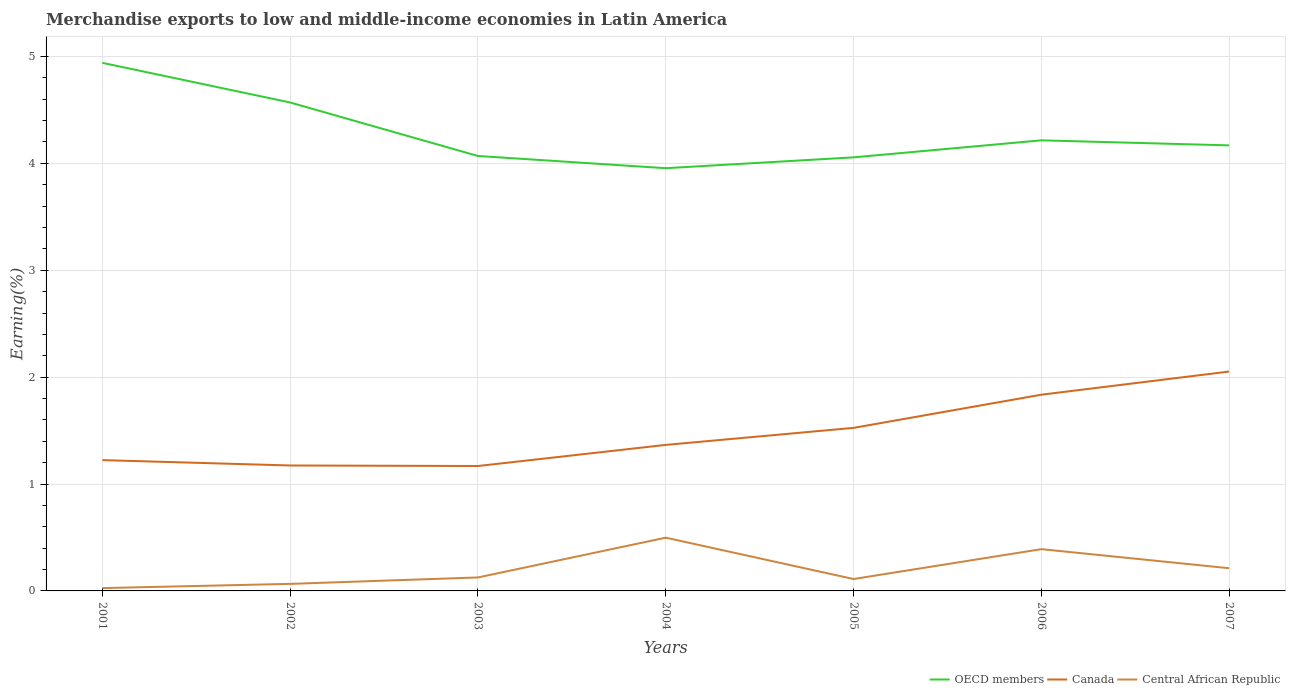How many different coloured lines are there?
Provide a short and direct response. 3. Across all years, what is the maximum percentage of amount earned from merchandise exports in OECD members?
Keep it short and to the point. 3.95. In which year was the percentage of amount earned from merchandise exports in Canada maximum?
Provide a succinct answer. 2003. What is the total percentage of amount earned from merchandise exports in Canada in the graph?
Give a very brief answer. -0.83. What is the difference between the highest and the second highest percentage of amount earned from merchandise exports in Canada?
Offer a terse response. 0.88. What is the difference between the highest and the lowest percentage of amount earned from merchandise exports in Central African Republic?
Your answer should be compact. 3. Is the percentage of amount earned from merchandise exports in Central African Republic strictly greater than the percentage of amount earned from merchandise exports in OECD members over the years?
Make the answer very short. Yes. How many years are there in the graph?
Your answer should be compact. 7. Are the values on the major ticks of Y-axis written in scientific E-notation?
Make the answer very short. No. Does the graph contain grids?
Offer a terse response. Yes. What is the title of the graph?
Your response must be concise. Merchandise exports to low and middle-income economies in Latin America. What is the label or title of the X-axis?
Your answer should be compact. Years. What is the label or title of the Y-axis?
Provide a succinct answer. Earning(%). What is the Earning(%) of OECD members in 2001?
Ensure brevity in your answer.  4.94. What is the Earning(%) in Canada in 2001?
Offer a very short reply. 1.22. What is the Earning(%) in Central African Republic in 2001?
Provide a succinct answer. 0.03. What is the Earning(%) in OECD members in 2002?
Your response must be concise. 4.57. What is the Earning(%) in Canada in 2002?
Provide a short and direct response. 1.17. What is the Earning(%) of Central African Republic in 2002?
Your answer should be compact. 0.07. What is the Earning(%) in OECD members in 2003?
Ensure brevity in your answer.  4.07. What is the Earning(%) of Canada in 2003?
Your answer should be compact. 1.17. What is the Earning(%) in Central African Republic in 2003?
Your answer should be compact. 0.13. What is the Earning(%) in OECD members in 2004?
Provide a succinct answer. 3.95. What is the Earning(%) of Canada in 2004?
Your answer should be very brief. 1.37. What is the Earning(%) of Central African Republic in 2004?
Your response must be concise. 0.5. What is the Earning(%) of OECD members in 2005?
Keep it short and to the point. 4.06. What is the Earning(%) of Canada in 2005?
Provide a short and direct response. 1.53. What is the Earning(%) of Central African Republic in 2005?
Make the answer very short. 0.11. What is the Earning(%) in OECD members in 2006?
Provide a succinct answer. 4.22. What is the Earning(%) in Canada in 2006?
Your answer should be very brief. 1.84. What is the Earning(%) in Central African Republic in 2006?
Ensure brevity in your answer.  0.39. What is the Earning(%) in OECD members in 2007?
Make the answer very short. 4.17. What is the Earning(%) of Canada in 2007?
Your answer should be compact. 2.05. What is the Earning(%) of Central African Republic in 2007?
Provide a succinct answer. 0.21. Across all years, what is the maximum Earning(%) of OECD members?
Your answer should be very brief. 4.94. Across all years, what is the maximum Earning(%) of Canada?
Make the answer very short. 2.05. Across all years, what is the maximum Earning(%) in Central African Republic?
Your response must be concise. 0.5. Across all years, what is the minimum Earning(%) of OECD members?
Your answer should be compact. 3.95. Across all years, what is the minimum Earning(%) in Canada?
Provide a succinct answer. 1.17. Across all years, what is the minimum Earning(%) in Central African Republic?
Provide a succinct answer. 0.03. What is the total Earning(%) in OECD members in the graph?
Your response must be concise. 29.97. What is the total Earning(%) of Canada in the graph?
Offer a terse response. 10.35. What is the total Earning(%) in Central African Republic in the graph?
Make the answer very short. 1.43. What is the difference between the Earning(%) of OECD members in 2001 and that in 2002?
Offer a terse response. 0.37. What is the difference between the Earning(%) in Canada in 2001 and that in 2002?
Ensure brevity in your answer.  0.05. What is the difference between the Earning(%) in Central African Republic in 2001 and that in 2002?
Provide a succinct answer. -0.04. What is the difference between the Earning(%) of OECD members in 2001 and that in 2003?
Provide a succinct answer. 0.87. What is the difference between the Earning(%) of Canada in 2001 and that in 2003?
Provide a short and direct response. 0.06. What is the difference between the Earning(%) in Central African Republic in 2001 and that in 2003?
Ensure brevity in your answer.  -0.1. What is the difference between the Earning(%) of OECD members in 2001 and that in 2004?
Keep it short and to the point. 0.99. What is the difference between the Earning(%) of Canada in 2001 and that in 2004?
Your answer should be compact. -0.14. What is the difference between the Earning(%) in Central African Republic in 2001 and that in 2004?
Your answer should be compact. -0.47. What is the difference between the Earning(%) in OECD members in 2001 and that in 2005?
Give a very brief answer. 0.88. What is the difference between the Earning(%) of Canada in 2001 and that in 2005?
Your answer should be very brief. -0.3. What is the difference between the Earning(%) in Central African Republic in 2001 and that in 2005?
Your answer should be very brief. -0.08. What is the difference between the Earning(%) in OECD members in 2001 and that in 2006?
Provide a succinct answer. 0.72. What is the difference between the Earning(%) in Canada in 2001 and that in 2006?
Provide a short and direct response. -0.61. What is the difference between the Earning(%) of Central African Republic in 2001 and that in 2006?
Offer a very short reply. -0.36. What is the difference between the Earning(%) of OECD members in 2001 and that in 2007?
Your answer should be very brief. 0.77. What is the difference between the Earning(%) of Canada in 2001 and that in 2007?
Your response must be concise. -0.83. What is the difference between the Earning(%) in Central African Republic in 2001 and that in 2007?
Make the answer very short. -0.19. What is the difference between the Earning(%) in OECD members in 2002 and that in 2003?
Provide a short and direct response. 0.5. What is the difference between the Earning(%) in Canada in 2002 and that in 2003?
Your response must be concise. 0. What is the difference between the Earning(%) in Central African Republic in 2002 and that in 2003?
Make the answer very short. -0.06. What is the difference between the Earning(%) of OECD members in 2002 and that in 2004?
Keep it short and to the point. 0.61. What is the difference between the Earning(%) of Canada in 2002 and that in 2004?
Provide a short and direct response. -0.19. What is the difference between the Earning(%) of Central African Republic in 2002 and that in 2004?
Your answer should be compact. -0.43. What is the difference between the Earning(%) in OECD members in 2002 and that in 2005?
Your answer should be compact. 0.51. What is the difference between the Earning(%) in Canada in 2002 and that in 2005?
Offer a very short reply. -0.35. What is the difference between the Earning(%) in Central African Republic in 2002 and that in 2005?
Keep it short and to the point. -0.05. What is the difference between the Earning(%) in OECD members in 2002 and that in 2006?
Make the answer very short. 0.35. What is the difference between the Earning(%) of Canada in 2002 and that in 2006?
Provide a short and direct response. -0.66. What is the difference between the Earning(%) of Central African Republic in 2002 and that in 2006?
Your answer should be very brief. -0.32. What is the difference between the Earning(%) in OECD members in 2002 and that in 2007?
Your answer should be compact. 0.4. What is the difference between the Earning(%) in Canada in 2002 and that in 2007?
Your answer should be very brief. -0.88. What is the difference between the Earning(%) in Central African Republic in 2002 and that in 2007?
Provide a short and direct response. -0.15. What is the difference between the Earning(%) of OECD members in 2003 and that in 2004?
Offer a very short reply. 0.11. What is the difference between the Earning(%) in Canada in 2003 and that in 2004?
Keep it short and to the point. -0.2. What is the difference between the Earning(%) of Central African Republic in 2003 and that in 2004?
Ensure brevity in your answer.  -0.37. What is the difference between the Earning(%) in OECD members in 2003 and that in 2005?
Provide a short and direct response. 0.01. What is the difference between the Earning(%) in Canada in 2003 and that in 2005?
Keep it short and to the point. -0.36. What is the difference between the Earning(%) of Central African Republic in 2003 and that in 2005?
Keep it short and to the point. 0.01. What is the difference between the Earning(%) in OECD members in 2003 and that in 2006?
Offer a terse response. -0.15. What is the difference between the Earning(%) in Canada in 2003 and that in 2006?
Give a very brief answer. -0.67. What is the difference between the Earning(%) of Central African Republic in 2003 and that in 2006?
Ensure brevity in your answer.  -0.26. What is the difference between the Earning(%) of OECD members in 2003 and that in 2007?
Your answer should be very brief. -0.1. What is the difference between the Earning(%) of Canada in 2003 and that in 2007?
Your response must be concise. -0.88. What is the difference between the Earning(%) of Central African Republic in 2003 and that in 2007?
Your answer should be compact. -0.09. What is the difference between the Earning(%) in OECD members in 2004 and that in 2005?
Offer a very short reply. -0.1. What is the difference between the Earning(%) of Canada in 2004 and that in 2005?
Give a very brief answer. -0.16. What is the difference between the Earning(%) in Central African Republic in 2004 and that in 2005?
Provide a short and direct response. 0.39. What is the difference between the Earning(%) of OECD members in 2004 and that in 2006?
Make the answer very short. -0.26. What is the difference between the Earning(%) of Canada in 2004 and that in 2006?
Your response must be concise. -0.47. What is the difference between the Earning(%) of Central African Republic in 2004 and that in 2006?
Your answer should be compact. 0.11. What is the difference between the Earning(%) in OECD members in 2004 and that in 2007?
Provide a short and direct response. -0.21. What is the difference between the Earning(%) in Canada in 2004 and that in 2007?
Your answer should be very brief. -0.69. What is the difference between the Earning(%) in Central African Republic in 2004 and that in 2007?
Make the answer very short. 0.29. What is the difference between the Earning(%) in OECD members in 2005 and that in 2006?
Give a very brief answer. -0.16. What is the difference between the Earning(%) of Canada in 2005 and that in 2006?
Offer a very short reply. -0.31. What is the difference between the Earning(%) of Central African Republic in 2005 and that in 2006?
Your response must be concise. -0.28. What is the difference between the Earning(%) of OECD members in 2005 and that in 2007?
Offer a terse response. -0.11. What is the difference between the Earning(%) in Canada in 2005 and that in 2007?
Give a very brief answer. -0.53. What is the difference between the Earning(%) in Central African Republic in 2005 and that in 2007?
Offer a very short reply. -0.1. What is the difference between the Earning(%) of OECD members in 2006 and that in 2007?
Offer a very short reply. 0.05. What is the difference between the Earning(%) of Canada in 2006 and that in 2007?
Ensure brevity in your answer.  -0.22. What is the difference between the Earning(%) in Central African Republic in 2006 and that in 2007?
Your answer should be very brief. 0.18. What is the difference between the Earning(%) in OECD members in 2001 and the Earning(%) in Canada in 2002?
Offer a very short reply. 3.77. What is the difference between the Earning(%) of OECD members in 2001 and the Earning(%) of Central African Republic in 2002?
Your answer should be compact. 4.87. What is the difference between the Earning(%) in Canada in 2001 and the Earning(%) in Central African Republic in 2002?
Ensure brevity in your answer.  1.16. What is the difference between the Earning(%) in OECD members in 2001 and the Earning(%) in Canada in 2003?
Your response must be concise. 3.77. What is the difference between the Earning(%) in OECD members in 2001 and the Earning(%) in Central African Republic in 2003?
Offer a terse response. 4.81. What is the difference between the Earning(%) in Canada in 2001 and the Earning(%) in Central African Republic in 2003?
Ensure brevity in your answer.  1.1. What is the difference between the Earning(%) in OECD members in 2001 and the Earning(%) in Canada in 2004?
Keep it short and to the point. 3.57. What is the difference between the Earning(%) of OECD members in 2001 and the Earning(%) of Central African Republic in 2004?
Your answer should be very brief. 4.44. What is the difference between the Earning(%) in Canada in 2001 and the Earning(%) in Central African Republic in 2004?
Your response must be concise. 0.73. What is the difference between the Earning(%) of OECD members in 2001 and the Earning(%) of Canada in 2005?
Your answer should be compact. 3.42. What is the difference between the Earning(%) in OECD members in 2001 and the Earning(%) in Central African Republic in 2005?
Your answer should be very brief. 4.83. What is the difference between the Earning(%) in Canada in 2001 and the Earning(%) in Central African Republic in 2005?
Provide a short and direct response. 1.11. What is the difference between the Earning(%) in OECD members in 2001 and the Earning(%) in Canada in 2006?
Provide a succinct answer. 3.1. What is the difference between the Earning(%) in OECD members in 2001 and the Earning(%) in Central African Republic in 2006?
Provide a short and direct response. 4.55. What is the difference between the Earning(%) in Canada in 2001 and the Earning(%) in Central African Republic in 2006?
Give a very brief answer. 0.83. What is the difference between the Earning(%) of OECD members in 2001 and the Earning(%) of Canada in 2007?
Ensure brevity in your answer.  2.89. What is the difference between the Earning(%) in OECD members in 2001 and the Earning(%) in Central African Republic in 2007?
Offer a very short reply. 4.73. What is the difference between the Earning(%) of Canada in 2001 and the Earning(%) of Central African Republic in 2007?
Your answer should be very brief. 1.01. What is the difference between the Earning(%) of OECD members in 2002 and the Earning(%) of Canada in 2003?
Offer a terse response. 3.4. What is the difference between the Earning(%) in OECD members in 2002 and the Earning(%) in Central African Republic in 2003?
Make the answer very short. 4.44. What is the difference between the Earning(%) of Canada in 2002 and the Earning(%) of Central African Republic in 2003?
Make the answer very short. 1.05. What is the difference between the Earning(%) of OECD members in 2002 and the Earning(%) of Canada in 2004?
Your answer should be very brief. 3.2. What is the difference between the Earning(%) in OECD members in 2002 and the Earning(%) in Central African Republic in 2004?
Provide a short and direct response. 4.07. What is the difference between the Earning(%) of Canada in 2002 and the Earning(%) of Central African Republic in 2004?
Your answer should be very brief. 0.68. What is the difference between the Earning(%) of OECD members in 2002 and the Earning(%) of Canada in 2005?
Offer a very short reply. 3.04. What is the difference between the Earning(%) of OECD members in 2002 and the Earning(%) of Central African Republic in 2005?
Offer a very short reply. 4.46. What is the difference between the Earning(%) of Canada in 2002 and the Earning(%) of Central African Republic in 2005?
Make the answer very short. 1.06. What is the difference between the Earning(%) of OECD members in 2002 and the Earning(%) of Canada in 2006?
Make the answer very short. 2.73. What is the difference between the Earning(%) in OECD members in 2002 and the Earning(%) in Central African Republic in 2006?
Your response must be concise. 4.18. What is the difference between the Earning(%) of Canada in 2002 and the Earning(%) of Central African Republic in 2006?
Make the answer very short. 0.78. What is the difference between the Earning(%) of OECD members in 2002 and the Earning(%) of Canada in 2007?
Give a very brief answer. 2.52. What is the difference between the Earning(%) of OECD members in 2002 and the Earning(%) of Central African Republic in 2007?
Give a very brief answer. 4.36. What is the difference between the Earning(%) of Canada in 2002 and the Earning(%) of Central African Republic in 2007?
Offer a terse response. 0.96. What is the difference between the Earning(%) of OECD members in 2003 and the Earning(%) of Canada in 2004?
Provide a short and direct response. 2.7. What is the difference between the Earning(%) in OECD members in 2003 and the Earning(%) in Central African Republic in 2004?
Ensure brevity in your answer.  3.57. What is the difference between the Earning(%) in Canada in 2003 and the Earning(%) in Central African Republic in 2004?
Offer a very short reply. 0.67. What is the difference between the Earning(%) of OECD members in 2003 and the Earning(%) of Canada in 2005?
Provide a short and direct response. 2.54. What is the difference between the Earning(%) in OECD members in 2003 and the Earning(%) in Central African Republic in 2005?
Keep it short and to the point. 3.96. What is the difference between the Earning(%) of Canada in 2003 and the Earning(%) of Central African Republic in 2005?
Your response must be concise. 1.06. What is the difference between the Earning(%) of OECD members in 2003 and the Earning(%) of Canada in 2006?
Provide a short and direct response. 2.23. What is the difference between the Earning(%) in OECD members in 2003 and the Earning(%) in Central African Republic in 2006?
Make the answer very short. 3.68. What is the difference between the Earning(%) of Canada in 2003 and the Earning(%) of Central African Republic in 2006?
Ensure brevity in your answer.  0.78. What is the difference between the Earning(%) in OECD members in 2003 and the Earning(%) in Canada in 2007?
Provide a succinct answer. 2.02. What is the difference between the Earning(%) of OECD members in 2003 and the Earning(%) of Central African Republic in 2007?
Make the answer very short. 3.86. What is the difference between the Earning(%) in Canada in 2003 and the Earning(%) in Central African Republic in 2007?
Your response must be concise. 0.96. What is the difference between the Earning(%) in OECD members in 2004 and the Earning(%) in Canada in 2005?
Give a very brief answer. 2.43. What is the difference between the Earning(%) of OECD members in 2004 and the Earning(%) of Central African Republic in 2005?
Offer a terse response. 3.84. What is the difference between the Earning(%) of Canada in 2004 and the Earning(%) of Central African Republic in 2005?
Your answer should be very brief. 1.25. What is the difference between the Earning(%) in OECD members in 2004 and the Earning(%) in Canada in 2006?
Provide a succinct answer. 2.12. What is the difference between the Earning(%) of OECD members in 2004 and the Earning(%) of Central African Republic in 2006?
Your answer should be compact. 3.56. What is the difference between the Earning(%) of Canada in 2004 and the Earning(%) of Central African Republic in 2006?
Keep it short and to the point. 0.98. What is the difference between the Earning(%) in OECD members in 2004 and the Earning(%) in Canada in 2007?
Give a very brief answer. 1.9. What is the difference between the Earning(%) in OECD members in 2004 and the Earning(%) in Central African Republic in 2007?
Provide a short and direct response. 3.74. What is the difference between the Earning(%) in Canada in 2004 and the Earning(%) in Central African Republic in 2007?
Make the answer very short. 1.15. What is the difference between the Earning(%) of OECD members in 2005 and the Earning(%) of Canada in 2006?
Ensure brevity in your answer.  2.22. What is the difference between the Earning(%) of OECD members in 2005 and the Earning(%) of Central African Republic in 2006?
Your answer should be compact. 3.67. What is the difference between the Earning(%) of Canada in 2005 and the Earning(%) of Central African Republic in 2006?
Make the answer very short. 1.13. What is the difference between the Earning(%) in OECD members in 2005 and the Earning(%) in Canada in 2007?
Offer a very short reply. 2. What is the difference between the Earning(%) of OECD members in 2005 and the Earning(%) of Central African Republic in 2007?
Make the answer very short. 3.84. What is the difference between the Earning(%) in Canada in 2005 and the Earning(%) in Central African Republic in 2007?
Your answer should be compact. 1.31. What is the difference between the Earning(%) in OECD members in 2006 and the Earning(%) in Canada in 2007?
Your response must be concise. 2.16. What is the difference between the Earning(%) in OECD members in 2006 and the Earning(%) in Central African Republic in 2007?
Your response must be concise. 4. What is the difference between the Earning(%) of Canada in 2006 and the Earning(%) of Central African Republic in 2007?
Your answer should be very brief. 1.62. What is the average Earning(%) of OECD members per year?
Your response must be concise. 4.28. What is the average Earning(%) of Canada per year?
Keep it short and to the point. 1.48. What is the average Earning(%) in Central African Republic per year?
Your answer should be compact. 0.2. In the year 2001, what is the difference between the Earning(%) of OECD members and Earning(%) of Canada?
Keep it short and to the point. 3.72. In the year 2001, what is the difference between the Earning(%) of OECD members and Earning(%) of Central African Republic?
Make the answer very short. 4.91. In the year 2001, what is the difference between the Earning(%) of Canada and Earning(%) of Central African Republic?
Keep it short and to the point. 1.2. In the year 2002, what is the difference between the Earning(%) in OECD members and Earning(%) in Canada?
Give a very brief answer. 3.4. In the year 2002, what is the difference between the Earning(%) of OECD members and Earning(%) of Central African Republic?
Keep it short and to the point. 4.5. In the year 2002, what is the difference between the Earning(%) in Canada and Earning(%) in Central African Republic?
Provide a short and direct response. 1.11. In the year 2003, what is the difference between the Earning(%) of OECD members and Earning(%) of Canada?
Your answer should be compact. 2.9. In the year 2003, what is the difference between the Earning(%) in OECD members and Earning(%) in Central African Republic?
Your response must be concise. 3.94. In the year 2003, what is the difference between the Earning(%) of Canada and Earning(%) of Central African Republic?
Keep it short and to the point. 1.04. In the year 2004, what is the difference between the Earning(%) of OECD members and Earning(%) of Canada?
Give a very brief answer. 2.59. In the year 2004, what is the difference between the Earning(%) of OECD members and Earning(%) of Central African Republic?
Your answer should be very brief. 3.46. In the year 2004, what is the difference between the Earning(%) of Canada and Earning(%) of Central African Republic?
Keep it short and to the point. 0.87. In the year 2005, what is the difference between the Earning(%) in OECD members and Earning(%) in Canada?
Give a very brief answer. 2.53. In the year 2005, what is the difference between the Earning(%) in OECD members and Earning(%) in Central African Republic?
Ensure brevity in your answer.  3.94. In the year 2005, what is the difference between the Earning(%) of Canada and Earning(%) of Central African Republic?
Offer a very short reply. 1.41. In the year 2006, what is the difference between the Earning(%) of OECD members and Earning(%) of Canada?
Your answer should be compact. 2.38. In the year 2006, what is the difference between the Earning(%) of OECD members and Earning(%) of Central African Republic?
Provide a succinct answer. 3.82. In the year 2006, what is the difference between the Earning(%) of Canada and Earning(%) of Central African Republic?
Ensure brevity in your answer.  1.45. In the year 2007, what is the difference between the Earning(%) in OECD members and Earning(%) in Canada?
Offer a very short reply. 2.12. In the year 2007, what is the difference between the Earning(%) of OECD members and Earning(%) of Central African Republic?
Your answer should be compact. 3.96. In the year 2007, what is the difference between the Earning(%) of Canada and Earning(%) of Central African Republic?
Your answer should be compact. 1.84. What is the ratio of the Earning(%) of OECD members in 2001 to that in 2002?
Offer a terse response. 1.08. What is the ratio of the Earning(%) in Canada in 2001 to that in 2002?
Offer a terse response. 1.04. What is the ratio of the Earning(%) in Central African Republic in 2001 to that in 2002?
Your answer should be very brief. 0.4. What is the ratio of the Earning(%) of OECD members in 2001 to that in 2003?
Ensure brevity in your answer.  1.21. What is the ratio of the Earning(%) of Canada in 2001 to that in 2003?
Give a very brief answer. 1.05. What is the ratio of the Earning(%) in Central African Republic in 2001 to that in 2003?
Offer a very short reply. 0.21. What is the ratio of the Earning(%) in OECD members in 2001 to that in 2004?
Provide a succinct answer. 1.25. What is the ratio of the Earning(%) in Canada in 2001 to that in 2004?
Keep it short and to the point. 0.9. What is the ratio of the Earning(%) of Central African Republic in 2001 to that in 2004?
Ensure brevity in your answer.  0.05. What is the ratio of the Earning(%) in OECD members in 2001 to that in 2005?
Your answer should be very brief. 1.22. What is the ratio of the Earning(%) in Canada in 2001 to that in 2005?
Your answer should be compact. 0.8. What is the ratio of the Earning(%) in Central African Republic in 2001 to that in 2005?
Offer a terse response. 0.24. What is the ratio of the Earning(%) of OECD members in 2001 to that in 2006?
Offer a terse response. 1.17. What is the ratio of the Earning(%) of Canada in 2001 to that in 2006?
Offer a terse response. 0.67. What is the ratio of the Earning(%) of Central African Republic in 2001 to that in 2006?
Offer a terse response. 0.07. What is the ratio of the Earning(%) of OECD members in 2001 to that in 2007?
Make the answer very short. 1.19. What is the ratio of the Earning(%) in Canada in 2001 to that in 2007?
Keep it short and to the point. 0.6. What is the ratio of the Earning(%) in Central African Republic in 2001 to that in 2007?
Your response must be concise. 0.12. What is the ratio of the Earning(%) of OECD members in 2002 to that in 2003?
Offer a very short reply. 1.12. What is the ratio of the Earning(%) of Central African Republic in 2002 to that in 2003?
Your answer should be very brief. 0.52. What is the ratio of the Earning(%) of OECD members in 2002 to that in 2004?
Provide a succinct answer. 1.16. What is the ratio of the Earning(%) of Canada in 2002 to that in 2004?
Keep it short and to the point. 0.86. What is the ratio of the Earning(%) in Central African Republic in 2002 to that in 2004?
Offer a terse response. 0.13. What is the ratio of the Earning(%) in OECD members in 2002 to that in 2005?
Make the answer very short. 1.13. What is the ratio of the Earning(%) of Canada in 2002 to that in 2005?
Offer a very short reply. 0.77. What is the ratio of the Earning(%) of Central African Republic in 2002 to that in 2005?
Ensure brevity in your answer.  0.59. What is the ratio of the Earning(%) in OECD members in 2002 to that in 2006?
Your response must be concise. 1.08. What is the ratio of the Earning(%) in Canada in 2002 to that in 2006?
Your answer should be very brief. 0.64. What is the ratio of the Earning(%) in Central African Republic in 2002 to that in 2006?
Your answer should be compact. 0.17. What is the ratio of the Earning(%) of OECD members in 2002 to that in 2007?
Keep it short and to the point. 1.1. What is the ratio of the Earning(%) of Canada in 2002 to that in 2007?
Provide a succinct answer. 0.57. What is the ratio of the Earning(%) of Central African Republic in 2002 to that in 2007?
Give a very brief answer. 0.31. What is the ratio of the Earning(%) in OECD members in 2003 to that in 2004?
Your answer should be very brief. 1.03. What is the ratio of the Earning(%) of Canada in 2003 to that in 2004?
Keep it short and to the point. 0.86. What is the ratio of the Earning(%) in Central African Republic in 2003 to that in 2004?
Offer a very short reply. 0.25. What is the ratio of the Earning(%) in OECD members in 2003 to that in 2005?
Make the answer very short. 1. What is the ratio of the Earning(%) in Canada in 2003 to that in 2005?
Your answer should be compact. 0.77. What is the ratio of the Earning(%) of Central African Republic in 2003 to that in 2005?
Your answer should be very brief. 1.13. What is the ratio of the Earning(%) of OECD members in 2003 to that in 2006?
Give a very brief answer. 0.97. What is the ratio of the Earning(%) of Canada in 2003 to that in 2006?
Your response must be concise. 0.64. What is the ratio of the Earning(%) in Central African Republic in 2003 to that in 2006?
Give a very brief answer. 0.32. What is the ratio of the Earning(%) of OECD members in 2003 to that in 2007?
Ensure brevity in your answer.  0.98. What is the ratio of the Earning(%) in Canada in 2003 to that in 2007?
Keep it short and to the point. 0.57. What is the ratio of the Earning(%) of Central African Republic in 2003 to that in 2007?
Your response must be concise. 0.59. What is the ratio of the Earning(%) in OECD members in 2004 to that in 2005?
Make the answer very short. 0.97. What is the ratio of the Earning(%) of Canada in 2004 to that in 2005?
Give a very brief answer. 0.9. What is the ratio of the Earning(%) of Central African Republic in 2004 to that in 2005?
Offer a terse response. 4.47. What is the ratio of the Earning(%) in OECD members in 2004 to that in 2006?
Keep it short and to the point. 0.94. What is the ratio of the Earning(%) in Canada in 2004 to that in 2006?
Provide a short and direct response. 0.74. What is the ratio of the Earning(%) in Central African Republic in 2004 to that in 2006?
Offer a terse response. 1.27. What is the ratio of the Earning(%) in OECD members in 2004 to that in 2007?
Provide a succinct answer. 0.95. What is the ratio of the Earning(%) in Canada in 2004 to that in 2007?
Your response must be concise. 0.67. What is the ratio of the Earning(%) of Central African Republic in 2004 to that in 2007?
Keep it short and to the point. 2.35. What is the ratio of the Earning(%) in OECD members in 2005 to that in 2006?
Ensure brevity in your answer.  0.96. What is the ratio of the Earning(%) of Canada in 2005 to that in 2006?
Ensure brevity in your answer.  0.83. What is the ratio of the Earning(%) of Central African Republic in 2005 to that in 2006?
Offer a terse response. 0.28. What is the ratio of the Earning(%) in OECD members in 2005 to that in 2007?
Your answer should be very brief. 0.97. What is the ratio of the Earning(%) in Canada in 2005 to that in 2007?
Offer a terse response. 0.74. What is the ratio of the Earning(%) in Central African Republic in 2005 to that in 2007?
Provide a succinct answer. 0.52. What is the ratio of the Earning(%) of OECD members in 2006 to that in 2007?
Keep it short and to the point. 1.01. What is the ratio of the Earning(%) in Canada in 2006 to that in 2007?
Your answer should be very brief. 0.89. What is the ratio of the Earning(%) of Central African Republic in 2006 to that in 2007?
Your response must be concise. 1.84. What is the difference between the highest and the second highest Earning(%) of OECD members?
Provide a short and direct response. 0.37. What is the difference between the highest and the second highest Earning(%) of Canada?
Your answer should be compact. 0.22. What is the difference between the highest and the second highest Earning(%) of Central African Republic?
Your response must be concise. 0.11. What is the difference between the highest and the lowest Earning(%) of OECD members?
Your answer should be compact. 0.99. What is the difference between the highest and the lowest Earning(%) in Canada?
Your answer should be very brief. 0.88. What is the difference between the highest and the lowest Earning(%) in Central African Republic?
Give a very brief answer. 0.47. 